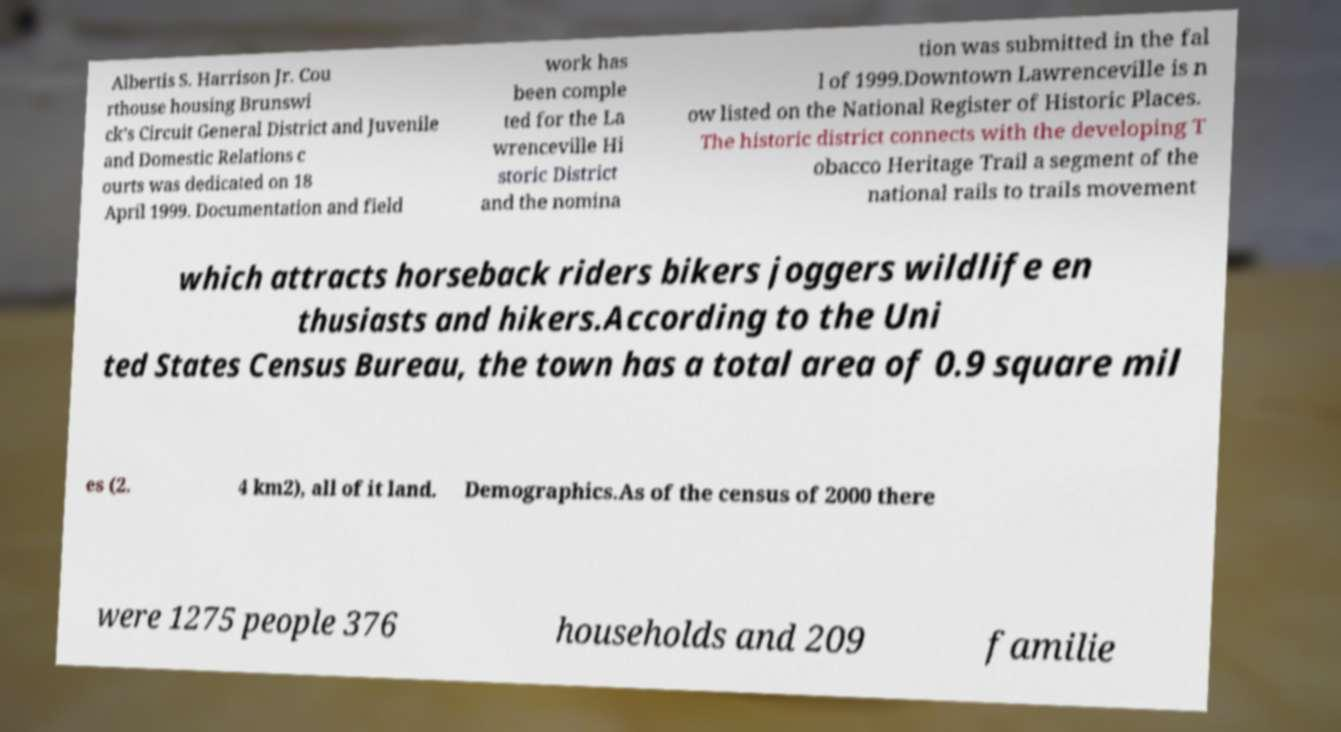Please read and relay the text visible in this image. What does it say? Albertis S. Harrison Jr. Cou rthouse housing Brunswi ck's Circuit General District and Juvenile and Domestic Relations c ourts was dedicated on 18 April 1999. Documentation and field work has been comple ted for the La wrenceville Hi storic District and the nomina tion was submitted in the fal l of 1999.Downtown Lawrenceville is n ow listed on the National Register of Historic Places. The historic district connects with the developing T obacco Heritage Trail a segment of the national rails to trails movement which attracts horseback riders bikers joggers wildlife en thusiasts and hikers.According to the Uni ted States Census Bureau, the town has a total area of 0.9 square mil es (2. 4 km2), all of it land. Demographics.As of the census of 2000 there were 1275 people 376 households and 209 familie 